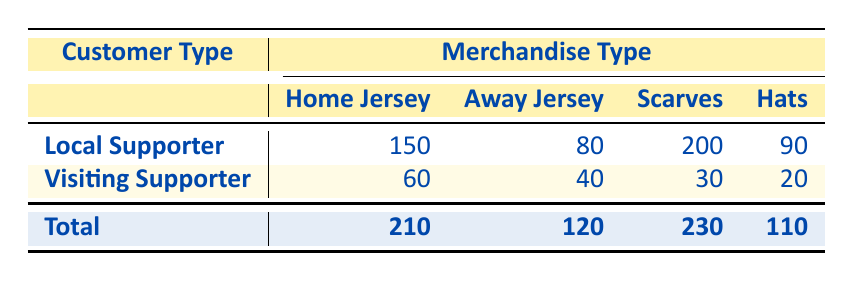What is the total quantity of Home Jerseys purchased by Local Supporters? Referring to the table, Local Supporters purchased 150 Home Jerseys.
Answer: 150 How many Scarves did Visiting Supporters purchase? According to the table, Visiting Supporters purchased 30 Scarves.
Answer: 30 What is the combined total quantity of merchandise purchased by both customer types? To find the total, we need to sum the totals for each merchandise type: 210 (Home Jerseys) + 120 (Away Jerseys) + 230 (Scarves) + 110 (Hats) = 770.
Answer: 770 Did Local Supporters purchase more Scarves than Visiting Supporters? Local Supporters purchased 200 Scarves, while Visiting Supporters purchased 30 Scarves. 200 is greater than 30, therefore yes.
Answer: Yes Which type of merchandise was the most popular among Local Supporters? The table shows that Local Supporters purchased 200 Scarves, which is the highest quantity compared to the other merchandise types.
Answer: Scarves What is the average quantity of Hats purchased across both customer types? To find the average, we need to sum the quantity of Hats purchased (90 by Local Supporters and 20 by Visiting Supporters) which gives us 110. Then we divide it by the number of customer types (2): 110 / 2 = 55.
Answer: 55 How many more Away Jerseys were purchased by Local Supporters compared to Visiting Supporters? Local Supporters purchased 80 Away Jerseys, while Visiting Supporters purchased 40. The difference is 80 - 40 = 40.
Answer: 40 What is the total number of Home Jerseys and Away Jerseys sold combined? The total for Home Jerseys is 210 and for Away Jerseys is 120. Adding these together gives us 210 + 120 = 330.
Answer: 330 Was the total quantity of merchandise purchased by Local Supporters greater than that of Visiting Supporters? The total for Local Supporters is 150 + 80 + 200 + 90 = 520, and for Visiting Supporters, it's 60 + 40 + 30 + 20 = 150. Since 520 is greater than 150, the answer is yes.
Answer: Yes 